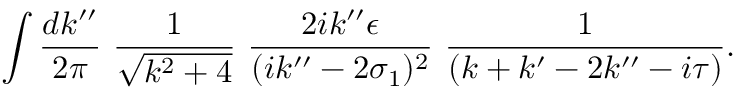Convert formula to latex. <formula><loc_0><loc_0><loc_500><loc_500>\int \frac { d k ^ { \prime \prime } } { 2 \pi } \, \frac { 1 } { \sqrt { k ^ { 2 } + 4 } } \, \frac { 2 i k ^ { \prime \prime } \epsilon } { ( i k ^ { \prime \prime } - 2 \sigma _ { 1 } ) ^ { 2 } } \, \frac { 1 } { ( k + k ^ { \prime } - 2 k ^ { \prime \prime } - i \tau ) } .</formula> 